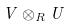<formula> <loc_0><loc_0><loc_500><loc_500>V \otimes _ { R } U</formula> 